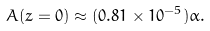<formula> <loc_0><loc_0><loc_500><loc_500>A ( z = 0 ) \approx ( 0 . 8 1 \times 1 0 ^ { - 5 } ) \alpha .</formula> 